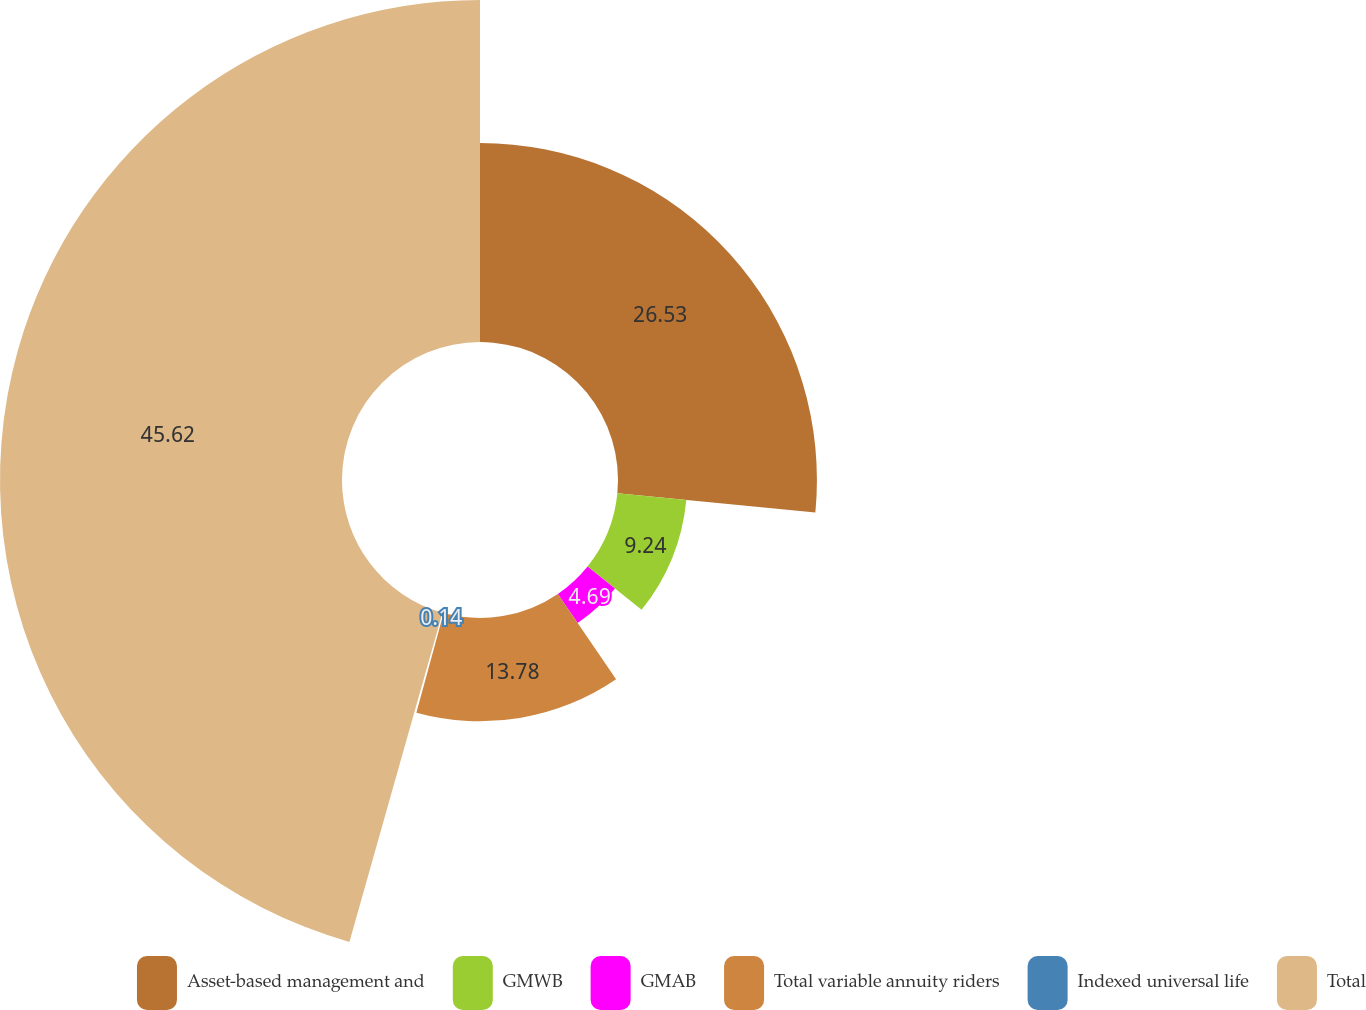Convert chart. <chart><loc_0><loc_0><loc_500><loc_500><pie_chart><fcel>Asset-based management and<fcel>GMWB<fcel>GMAB<fcel>Total variable annuity riders<fcel>Indexed universal life<fcel>Total<nl><fcel>26.53%<fcel>9.24%<fcel>4.69%<fcel>13.78%<fcel>0.14%<fcel>45.61%<nl></chart> 